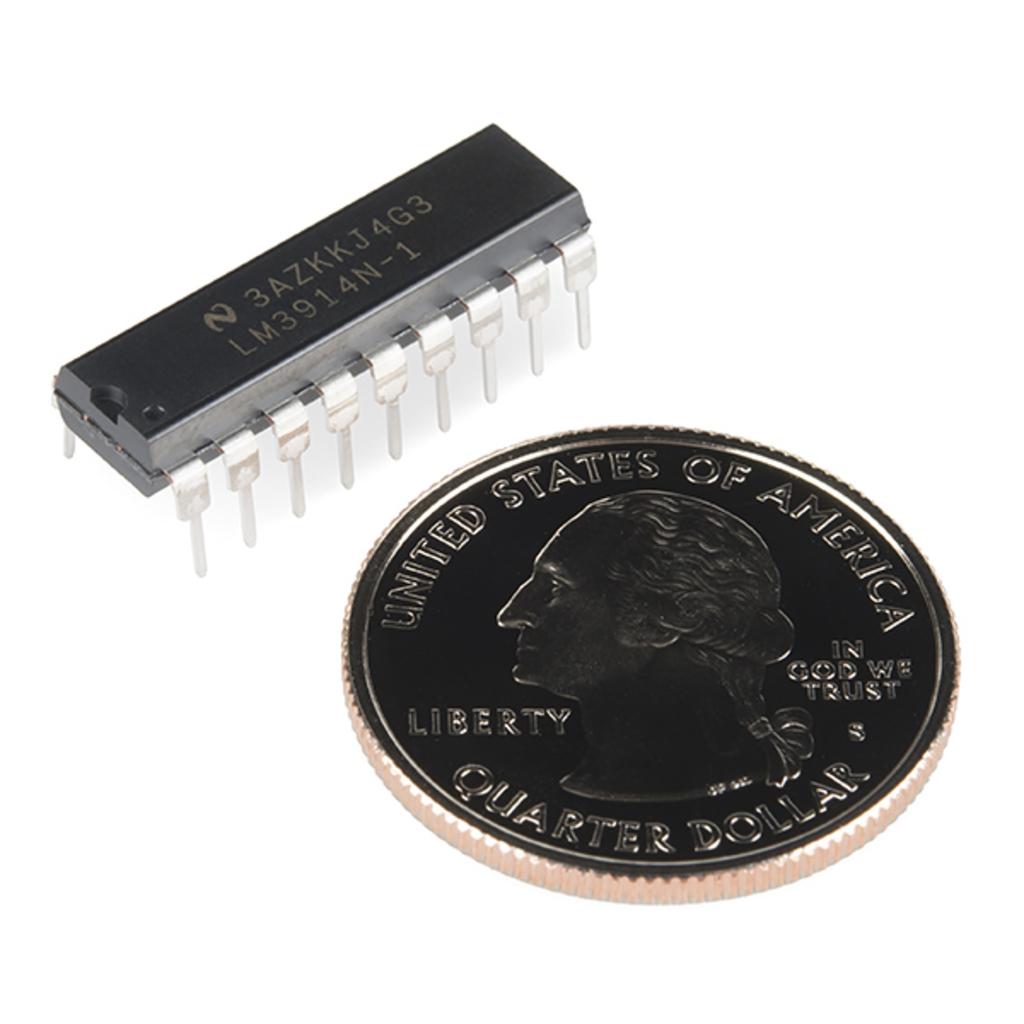What country is this coin from?
Offer a very short reply. United states of america. What is the coin worth?
Offer a terse response. Quarter dollar. 